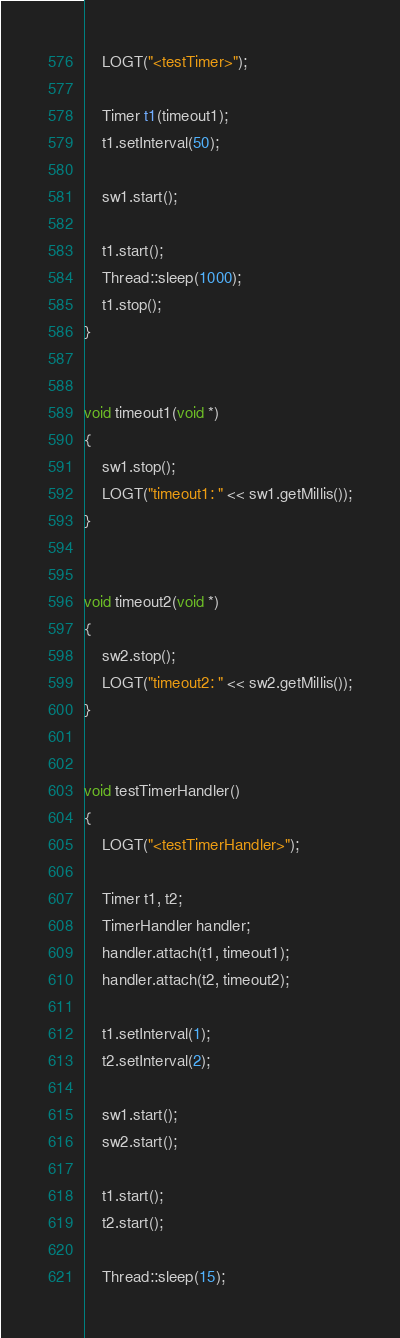Convert code to text. <code><loc_0><loc_0><loc_500><loc_500><_C++_>	LOGT("<testTimer>");

	Timer t1(timeout1);
	t1.setInterval(50);

	sw1.start();

	t1.start();
	Thread::sleep(1000);
	t1.stop();
}


void timeout1(void *)
{
	sw1.stop();
	LOGT("timeout1: " << sw1.getMillis());
}


void timeout2(void *)
{
	sw2.stop();
	LOGT("timeout2: " << sw2.getMillis());
}


void testTimerHandler()
{
	LOGT("<testTimerHandler>");

	Timer t1, t2;
	TimerHandler handler;
	handler.attach(t1, timeout1);
	handler.attach(t2, timeout2);

	t1.setInterval(1);
	t2.setInterval(2);

	sw1.start();
	sw2.start();

	t1.start();
	t2.start();

	Thread::sleep(15);</code> 